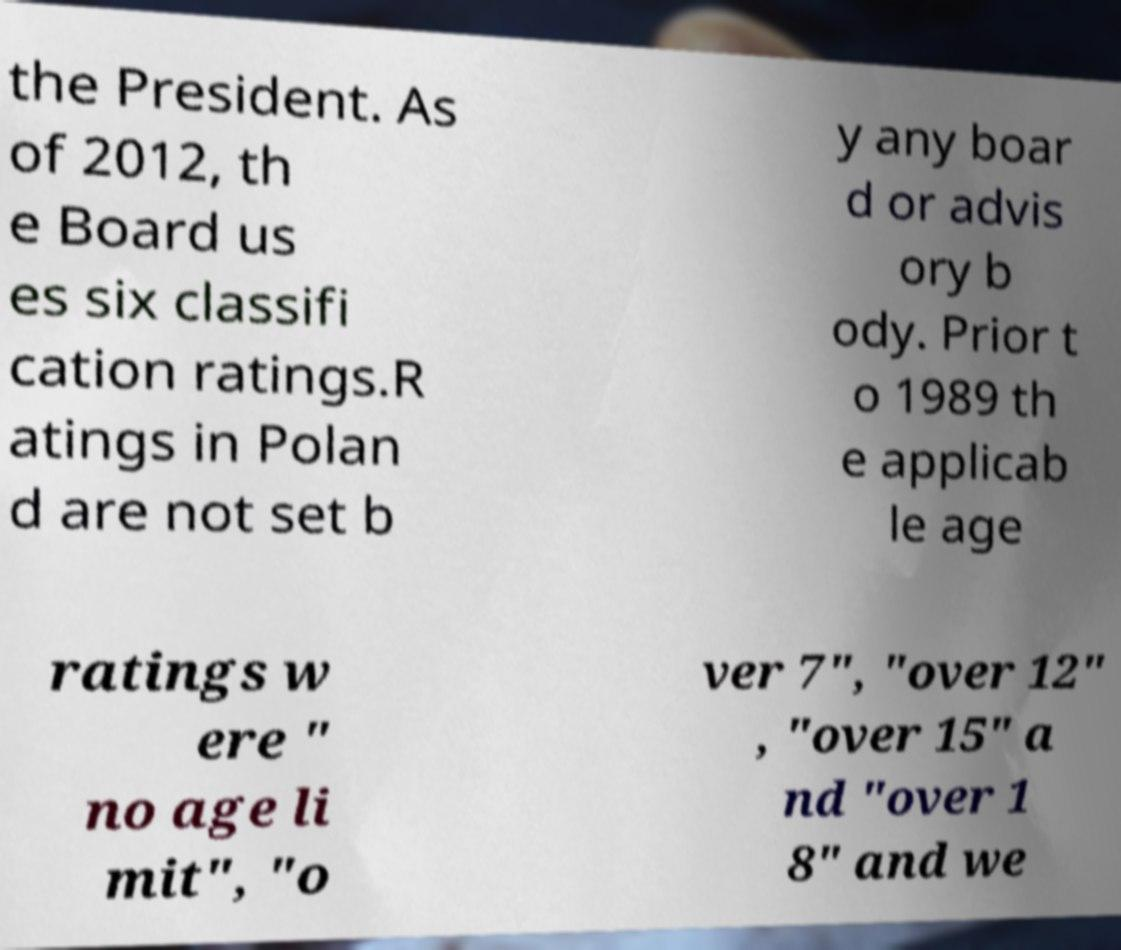Please read and relay the text visible in this image. What does it say? the President. As of 2012, th e Board us es six classifi cation ratings.R atings in Polan d are not set b y any boar d or advis ory b ody. Prior t o 1989 th e applicab le age ratings w ere " no age li mit", "o ver 7", "over 12" , "over 15" a nd "over 1 8" and we 